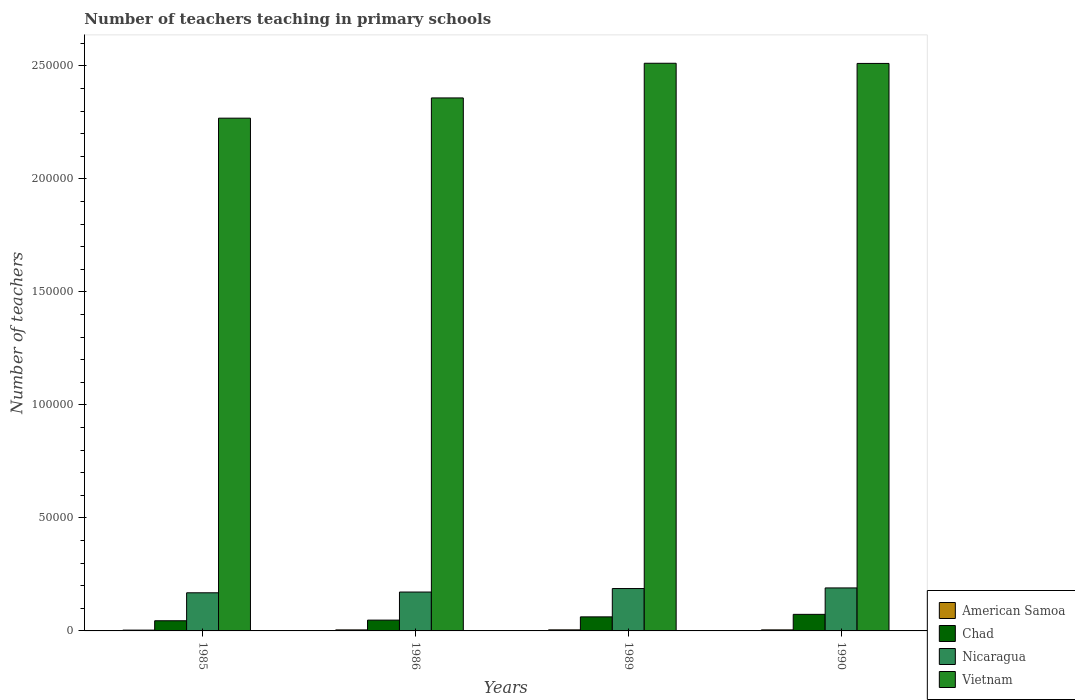How many different coloured bars are there?
Your answer should be compact. 4. How many groups of bars are there?
Keep it short and to the point. 4. Are the number of bars per tick equal to the number of legend labels?
Your answer should be very brief. Yes. Are the number of bars on each tick of the X-axis equal?
Keep it short and to the point. Yes. How many bars are there on the 1st tick from the right?
Provide a short and direct response. 4. What is the number of teachers teaching in primary schools in American Samoa in 1989?
Provide a succinct answer. 469. Across all years, what is the maximum number of teachers teaching in primary schools in Nicaragua?
Ensure brevity in your answer.  1.90e+04. Across all years, what is the minimum number of teachers teaching in primary schools in Chad?
Your answer should be very brief. 4494. What is the total number of teachers teaching in primary schools in Vietnam in the graph?
Keep it short and to the point. 9.65e+05. What is the difference between the number of teachers teaching in primary schools in Vietnam in 1986 and that in 1990?
Your answer should be compact. -1.53e+04. What is the difference between the number of teachers teaching in primary schools in Nicaragua in 1989 and the number of teachers teaching in primary schools in American Samoa in 1985?
Make the answer very short. 1.84e+04. What is the average number of teachers teaching in primary schools in Vietnam per year?
Ensure brevity in your answer.  2.41e+05. In the year 1985, what is the difference between the number of teachers teaching in primary schools in Nicaragua and number of teachers teaching in primary schools in Vietnam?
Give a very brief answer. -2.10e+05. What is the ratio of the number of teachers teaching in primary schools in Chad in 1986 to that in 1989?
Your answer should be compact. 0.77. Is the difference between the number of teachers teaching in primary schools in Nicaragua in 1985 and 1990 greater than the difference between the number of teachers teaching in primary schools in Vietnam in 1985 and 1990?
Provide a short and direct response. Yes. What is the difference between the highest and the lowest number of teachers teaching in primary schools in Nicaragua?
Your answer should be very brief. 2150. In how many years, is the number of teachers teaching in primary schools in American Samoa greater than the average number of teachers teaching in primary schools in American Samoa taken over all years?
Ensure brevity in your answer.  3. Is the sum of the number of teachers teaching in primary schools in Nicaragua in 1986 and 1990 greater than the maximum number of teachers teaching in primary schools in Chad across all years?
Offer a very short reply. Yes. What does the 3rd bar from the left in 1989 represents?
Provide a succinct answer. Nicaragua. What does the 2nd bar from the right in 1985 represents?
Ensure brevity in your answer.  Nicaragua. Is it the case that in every year, the sum of the number of teachers teaching in primary schools in American Samoa and number of teachers teaching in primary schools in Nicaragua is greater than the number of teachers teaching in primary schools in Vietnam?
Offer a terse response. No. How many bars are there?
Your answer should be compact. 16. How many years are there in the graph?
Your answer should be very brief. 4. What is the difference between two consecutive major ticks on the Y-axis?
Provide a succinct answer. 5.00e+04. Are the values on the major ticks of Y-axis written in scientific E-notation?
Keep it short and to the point. No. Does the graph contain any zero values?
Offer a very short reply. No. Does the graph contain grids?
Offer a terse response. No. How are the legend labels stacked?
Keep it short and to the point. Vertical. What is the title of the graph?
Ensure brevity in your answer.  Number of teachers teaching in primary schools. Does "Rwanda" appear as one of the legend labels in the graph?
Offer a terse response. No. What is the label or title of the X-axis?
Your response must be concise. Years. What is the label or title of the Y-axis?
Keep it short and to the point. Number of teachers. What is the Number of teachers of American Samoa in 1985?
Provide a succinct answer. 359. What is the Number of teachers of Chad in 1985?
Provide a succinct answer. 4494. What is the Number of teachers of Nicaragua in 1985?
Provide a succinct answer. 1.69e+04. What is the Number of teachers in Vietnam in 1985?
Offer a very short reply. 2.27e+05. What is the Number of teachers of American Samoa in 1986?
Offer a very short reply. 454. What is the Number of teachers of Chad in 1986?
Keep it short and to the point. 4779. What is the Number of teachers in Nicaragua in 1986?
Your answer should be very brief. 1.72e+04. What is the Number of teachers in Vietnam in 1986?
Provide a succinct answer. 2.36e+05. What is the Number of teachers of American Samoa in 1989?
Provide a short and direct response. 469. What is the Number of teachers of Chad in 1989?
Your answer should be very brief. 6215. What is the Number of teachers in Nicaragua in 1989?
Ensure brevity in your answer.  1.87e+04. What is the Number of teachers in Vietnam in 1989?
Offer a very short reply. 2.51e+05. What is the Number of teachers of American Samoa in 1990?
Your response must be concise. 461. What is the Number of teachers of Chad in 1990?
Offer a terse response. 7327. What is the Number of teachers in Nicaragua in 1990?
Your response must be concise. 1.90e+04. What is the Number of teachers of Vietnam in 1990?
Provide a succinct answer. 2.51e+05. Across all years, what is the maximum Number of teachers of American Samoa?
Your answer should be compact. 469. Across all years, what is the maximum Number of teachers in Chad?
Offer a very short reply. 7327. Across all years, what is the maximum Number of teachers in Nicaragua?
Your response must be concise. 1.90e+04. Across all years, what is the maximum Number of teachers of Vietnam?
Your answer should be very brief. 2.51e+05. Across all years, what is the minimum Number of teachers of American Samoa?
Provide a short and direct response. 359. Across all years, what is the minimum Number of teachers of Chad?
Make the answer very short. 4494. Across all years, what is the minimum Number of teachers in Nicaragua?
Give a very brief answer. 1.69e+04. Across all years, what is the minimum Number of teachers of Vietnam?
Keep it short and to the point. 2.27e+05. What is the total Number of teachers in American Samoa in the graph?
Provide a short and direct response. 1743. What is the total Number of teachers of Chad in the graph?
Offer a terse response. 2.28e+04. What is the total Number of teachers of Nicaragua in the graph?
Your answer should be very brief. 7.18e+04. What is the total Number of teachers in Vietnam in the graph?
Your response must be concise. 9.65e+05. What is the difference between the Number of teachers in American Samoa in 1985 and that in 1986?
Offer a very short reply. -95. What is the difference between the Number of teachers in Chad in 1985 and that in 1986?
Your answer should be very brief. -285. What is the difference between the Number of teachers in Nicaragua in 1985 and that in 1986?
Your answer should be very brief. -327. What is the difference between the Number of teachers of Vietnam in 1985 and that in 1986?
Provide a short and direct response. -8955. What is the difference between the Number of teachers of American Samoa in 1985 and that in 1989?
Your response must be concise. -110. What is the difference between the Number of teachers of Chad in 1985 and that in 1989?
Offer a terse response. -1721. What is the difference between the Number of teachers in Nicaragua in 1985 and that in 1989?
Provide a succinct answer. -1874. What is the difference between the Number of teachers of Vietnam in 1985 and that in 1989?
Keep it short and to the point. -2.43e+04. What is the difference between the Number of teachers of American Samoa in 1985 and that in 1990?
Offer a terse response. -102. What is the difference between the Number of teachers in Chad in 1985 and that in 1990?
Provide a short and direct response. -2833. What is the difference between the Number of teachers of Nicaragua in 1985 and that in 1990?
Your answer should be compact. -2150. What is the difference between the Number of teachers in Vietnam in 1985 and that in 1990?
Give a very brief answer. -2.42e+04. What is the difference between the Number of teachers of Chad in 1986 and that in 1989?
Make the answer very short. -1436. What is the difference between the Number of teachers in Nicaragua in 1986 and that in 1989?
Your answer should be compact. -1547. What is the difference between the Number of teachers of Vietnam in 1986 and that in 1989?
Give a very brief answer. -1.53e+04. What is the difference between the Number of teachers in Chad in 1986 and that in 1990?
Give a very brief answer. -2548. What is the difference between the Number of teachers in Nicaragua in 1986 and that in 1990?
Your response must be concise. -1823. What is the difference between the Number of teachers of Vietnam in 1986 and that in 1990?
Give a very brief answer. -1.53e+04. What is the difference between the Number of teachers in American Samoa in 1989 and that in 1990?
Ensure brevity in your answer.  8. What is the difference between the Number of teachers of Chad in 1989 and that in 1990?
Give a very brief answer. -1112. What is the difference between the Number of teachers in Nicaragua in 1989 and that in 1990?
Offer a very short reply. -276. What is the difference between the Number of teachers in American Samoa in 1985 and the Number of teachers in Chad in 1986?
Offer a very short reply. -4420. What is the difference between the Number of teachers in American Samoa in 1985 and the Number of teachers in Nicaragua in 1986?
Provide a succinct answer. -1.68e+04. What is the difference between the Number of teachers of American Samoa in 1985 and the Number of teachers of Vietnam in 1986?
Provide a succinct answer. -2.35e+05. What is the difference between the Number of teachers in Chad in 1985 and the Number of teachers in Nicaragua in 1986?
Offer a very short reply. -1.27e+04. What is the difference between the Number of teachers of Chad in 1985 and the Number of teachers of Vietnam in 1986?
Provide a succinct answer. -2.31e+05. What is the difference between the Number of teachers in Nicaragua in 1985 and the Number of teachers in Vietnam in 1986?
Your answer should be very brief. -2.19e+05. What is the difference between the Number of teachers of American Samoa in 1985 and the Number of teachers of Chad in 1989?
Offer a very short reply. -5856. What is the difference between the Number of teachers in American Samoa in 1985 and the Number of teachers in Nicaragua in 1989?
Offer a very short reply. -1.84e+04. What is the difference between the Number of teachers in American Samoa in 1985 and the Number of teachers in Vietnam in 1989?
Offer a very short reply. -2.51e+05. What is the difference between the Number of teachers of Chad in 1985 and the Number of teachers of Nicaragua in 1989?
Provide a succinct answer. -1.43e+04. What is the difference between the Number of teachers in Chad in 1985 and the Number of teachers in Vietnam in 1989?
Your response must be concise. -2.47e+05. What is the difference between the Number of teachers of Nicaragua in 1985 and the Number of teachers of Vietnam in 1989?
Offer a terse response. -2.34e+05. What is the difference between the Number of teachers of American Samoa in 1985 and the Number of teachers of Chad in 1990?
Offer a terse response. -6968. What is the difference between the Number of teachers of American Samoa in 1985 and the Number of teachers of Nicaragua in 1990?
Provide a succinct answer. -1.87e+04. What is the difference between the Number of teachers of American Samoa in 1985 and the Number of teachers of Vietnam in 1990?
Your answer should be very brief. -2.51e+05. What is the difference between the Number of teachers in Chad in 1985 and the Number of teachers in Nicaragua in 1990?
Your answer should be compact. -1.45e+04. What is the difference between the Number of teachers of Chad in 1985 and the Number of teachers of Vietnam in 1990?
Offer a very short reply. -2.47e+05. What is the difference between the Number of teachers in Nicaragua in 1985 and the Number of teachers in Vietnam in 1990?
Keep it short and to the point. -2.34e+05. What is the difference between the Number of teachers in American Samoa in 1986 and the Number of teachers in Chad in 1989?
Make the answer very short. -5761. What is the difference between the Number of teachers of American Samoa in 1986 and the Number of teachers of Nicaragua in 1989?
Your answer should be compact. -1.83e+04. What is the difference between the Number of teachers in American Samoa in 1986 and the Number of teachers in Vietnam in 1989?
Your response must be concise. -2.51e+05. What is the difference between the Number of teachers of Chad in 1986 and the Number of teachers of Nicaragua in 1989?
Provide a short and direct response. -1.40e+04. What is the difference between the Number of teachers in Chad in 1986 and the Number of teachers in Vietnam in 1989?
Give a very brief answer. -2.46e+05. What is the difference between the Number of teachers of Nicaragua in 1986 and the Number of teachers of Vietnam in 1989?
Provide a succinct answer. -2.34e+05. What is the difference between the Number of teachers of American Samoa in 1986 and the Number of teachers of Chad in 1990?
Your answer should be very brief. -6873. What is the difference between the Number of teachers in American Samoa in 1986 and the Number of teachers in Nicaragua in 1990?
Provide a short and direct response. -1.86e+04. What is the difference between the Number of teachers in American Samoa in 1986 and the Number of teachers in Vietnam in 1990?
Your response must be concise. -2.51e+05. What is the difference between the Number of teachers of Chad in 1986 and the Number of teachers of Nicaragua in 1990?
Offer a terse response. -1.42e+04. What is the difference between the Number of teachers of Chad in 1986 and the Number of teachers of Vietnam in 1990?
Provide a succinct answer. -2.46e+05. What is the difference between the Number of teachers in Nicaragua in 1986 and the Number of teachers in Vietnam in 1990?
Provide a short and direct response. -2.34e+05. What is the difference between the Number of teachers in American Samoa in 1989 and the Number of teachers in Chad in 1990?
Your response must be concise. -6858. What is the difference between the Number of teachers in American Samoa in 1989 and the Number of teachers in Nicaragua in 1990?
Your response must be concise. -1.86e+04. What is the difference between the Number of teachers of American Samoa in 1989 and the Number of teachers of Vietnam in 1990?
Give a very brief answer. -2.51e+05. What is the difference between the Number of teachers of Chad in 1989 and the Number of teachers of Nicaragua in 1990?
Ensure brevity in your answer.  -1.28e+04. What is the difference between the Number of teachers of Chad in 1989 and the Number of teachers of Vietnam in 1990?
Give a very brief answer. -2.45e+05. What is the difference between the Number of teachers in Nicaragua in 1989 and the Number of teachers in Vietnam in 1990?
Your answer should be very brief. -2.32e+05. What is the average Number of teachers in American Samoa per year?
Make the answer very short. 435.75. What is the average Number of teachers of Chad per year?
Offer a terse response. 5703.75. What is the average Number of teachers of Nicaragua per year?
Your response must be concise. 1.80e+04. What is the average Number of teachers in Vietnam per year?
Your answer should be very brief. 2.41e+05. In the year 1985, what is the difference between the Number of teachers in American Samoa and Number of teachers in Chad?
Make the answer very short. -4135. In the year 1985, what is the difference between the Number of teachers in American Samoa and Number of teachers in Nicaragua?
Your answer should be very brief. -1.65e+04. In the year 1985, what is the difference between the Number of teachers of American Samoa and Number of teachers of Vietnam?
Your answer should be compact. -2.26e+05. In the year 1985, what is the difference between the Number of teachers in Chad and Number of teachers in Nicaragua?
Give a very brief answer. -1.24e+04. In the year 1985, what is the difference between the Number of teachers in Chad and Number of teachers in Vietnam?
Your response must be concise. -2.22e+05. In the year 1985, what is the difference between the Number of teachers in Nicaragua and Number of teachers in Vietnam?
Ensure brevity in your answer.  -2.10e+05. In the year 1986, what is the difference between the Number of teachers of American Samoa and Number of teachers of Chad?
Offer a very short reply. -4325. In the year 1986, what is the difference between the Number of teachers in American Samoa and Number of teachers in Nicaragua?
Provide a short and direct response. -1.67e+04. In the year 1986, what is the difference between the Number of teachers of American Samoa and Number of teachers of Vietnam?
Give a very brief answer. -2.35e+05. In the year 1986, what is the difference between the Number of teachers of Chad and Number of teachers of Nicaragua?
Offer a terse response. -1.24e+04. In the year 1986, what is the difference between the Number of teachers of Chad and Number of teachers of Vietnam?
Provide a succinct answer. -2.31e+05. In the year 1986, what is the difference between the Number of teachers in Nicaragua and Number of teachers in Vietnam?
Provide a succinct answer. -2.19e+05. In the year 1989, what is the difference between the Number of teachers of American Samoa and Number of teachers of Chad?
Give a very brief answer. -5746. In the year 1989, what is the difference between the Number of teachers of American Samoa and Number of teachers of Nicaragua?
Your response must be concise. -1.83e+04. In the year 1989, what is the difference between the Number of teachers of American Samoa and Number of teachers of Vietnam?
Give a very brief answer. -2.51e+05. In the year 1989, what is the difference between the Number of teachers of Chad and Number of teachers of Nicaragua?
Offer a terse response. -1.25e+04. In the year 1989, what is the difference between the Number of teachers of Chad and Number of teachers of Vietnam?
Provide a succinct answer. -2.45e+05. In the year 1989, what is the difference between the Number of teachers of Nicaragua and Number of teachers of Vietnam?
Keep it short and to the point. -2.32e+05. In the year 1990, what is the difference between the Number of teachers of American Samoa and Number of teachers of Chad?
Keep it short and to the point. -6866. In the year 1990, what is the difference between the Number of teachers in American Samoa and Number of teachers in Nicaragua?
Your response must be concise. -1.86e+04. In the year 1990, what is the difference between the Number of teachers in American Samoa and Number of teachers in Vietnam?
Give a very brief answer. -2.51e+05. In the year 1990, what is the difference between the Number of teachers in Chad and Number of teachers in Nicaragua?
Provide a succinct answer. -1.17e+04. In the year 1990, what is the difference between the Number of teachers of Chad and Number of teachers of Vietnam?
Make the answer very short. -2.44e+05. In the year 1990, what is the difference between the Number of teachers in Nicaragua and Number of teachers in Vietnam?
Give a very brief answer. -2.32e+05. What is the ratio of the Number of teachers in American Samoa in 1985 to that in 1986?
Your answer should be compact. 0.79. What is the ratio of the Number of teachers in Chad in 1985 to that in 1986?
Make the answer very short. 0.94. What is the ratio of the Number of teachers of Nicaragua in 1985 to that in 1986?
Ensure brevity in your answer.  0.98. What is the ratio of the Number of teachers of American Samoa in 1985 to that in 1989?
Ensure brevity in your answer.  0.77. What is the ratio of the Number of teachers of Chad in 1985 to that in 1989?
Provide a succinct answer. 0.72. What is the ratio of the Number of teachers in Vietnam in 1985 to that in 1989?
Give a very brief answer. 0.9. What is the ratio of the Number of teachers of American Samoa in 1985 to that in 1990?
Your answer should be compact. 0.78. What is the ratio of the Number of teachers in Chad in 1985 to that in 1990?
Provide a short and direct response. 0.61. What is the ratio of the Number of teachers in Nicaragua in 1985 to that in 1990?
Provide a short and direct response. 0.89. What is the ratio of the Number of teachers in Vietnam in 1985 to that in 1990?
Your response must be concise. 0.9. What is the ratio of the Number of teachers in American Samoa in 1986 to that in 1989?
Provide a succinct answer. 0.97. What is the ratio of the Number of teachers in Chad in 1986 to that in 1989?
Make the answer very short. 0.77. What is the ratio of the Number of teachers in Nicaragua in 1986 to that in 1989?
Provide a succinct answer. 0.92. What is the ratio of the Number of teachers in Vietnam in 1986 to that in 1989?
Provide a short and direct response. 0.94. What is the ratio of the Number of teachers of American Samoa in 1986 to that in 1990?
Provide a short and direct response. 0.98. What is the ratio of the Number of teachers in Chad in 1986 to that in 1990?
Provide a short and direct response. 0.65. What is the ratio of the Number of teachers of Nicaragua in 1986 to that in 1990?
Your answer should be compact. 0.9. What is the ratio of the Number of teachers of Vietnam in 1986 to that in 1990?
Offer a very short reply. 0.94. What is the ratio of the Number of teachers of American Samoa in 1989 to that in 1990?
Keep it short and to the point. 1.02. What is the ratio of the Number of teachers in Chad in 1989 to that in 1990?
Provide a short and direct response. 0.85. What is the ratio of the Number of teachers in Nicaragua in 1989 to that in 1990?
Offer a terse response. 0.99. What is the ratio of the Number of teachers in Vietnam in 1989 to that in 1990?
Provide a succinct answer. 1. What is the difference between the highest and the second highest Number of teachers of American Samoa?
Offer a very short reply. 8. What is the difference between the highest and the second highest Number of teachers in Chad?
Give a very brief answer. 1112. What is the difference between the highest and the second highest Number of teachers of Nicaragua?
Offer a very short reply. 276. What is the difference between the highest and the second highest Number of teachers in Vietnam?
Offer a very short reply. 75. What is the difference between the highest and the lowest Number of teachers of American Samoa?
Keep it short and to the point. 110. What is the difference between the highest and the lowest Number of teachers in Chad?
Your answer should be very brief. 2833. What is the difference between the highest and the lowest Number of teachers of Nicaragua?
Offer a terse response. 2150. What is the difference between the highest and the lowest Number of teachers of Vietnam?
Keep it short and to the point. 2.43e+04. 